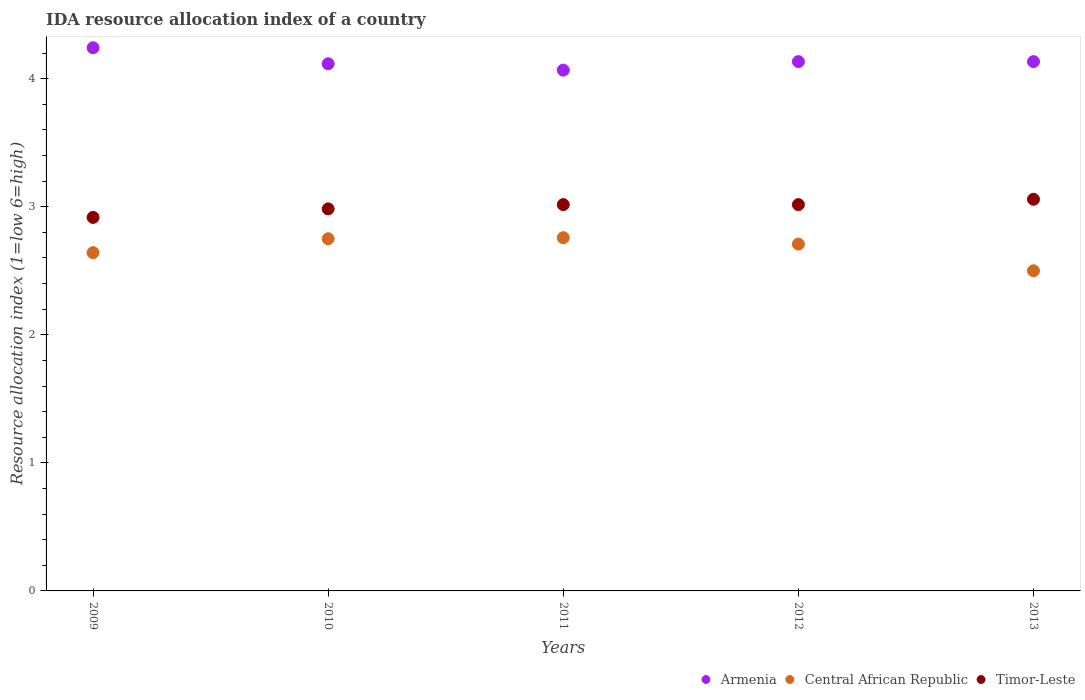How many different coloured dotlines are there?
Make the answer very short. 3. What is the IDA resource allocation index in Armenia in 2009?
Ensure brevity in your answer.  4.24. Across all years, what is the maximum IDA resource allocation index in Armenia?
Offer a very short reply. 4.24. What is the total IDA resource allocation index in Central African Republic in the graph?
Your response must be concise. 13.36. What is the difference between the IDA resource allocation index in Central African Republic in 2011 and that in 2012?
Give a very brief answer. 0.05. What is the difference between the IDA resource allocation index in Central African Republic in 2011 and the IDA resource allocation index in Armenia in 2012?
Your answer should be very brief. -1.38. What is the average IDA resource allocation index in Central African Republic per year?
Your response must be concise. 2.67. In the year 2011, what is the difference between the IDA resource allocation index in Timor-Leste and IDA resource allocation index in Central African Republic?
Offer a terse response. 0.26. In how many years, is the IDA resource allocation index in Armenia greater than 0.2?
Ensure brevity in your answer.  5. What is the ratio of the IDA resource allocation index in Timor-Leste in 2010 to that in 2013?
Provide a succinct answer. 0.98. Is the difference between the IDA resource allocation index in Timor-Leste in 2009 and 2011 greater than the difference between the IDA resource allocation index in Central African Republic in 2009 and 2011?
Offer a very short reply. Yes. What is the difference between the highest and the second highest IDA resource allocation index in Timor-Leste?
Provide a short and direct response. 0.04. What is the difference between the highest and the lowest IDA resource allocation index in Timor-Leste?
Your answer should be compact. 0.14. In how many years, is the IDA resource allocation index in Armenia greater than the average IDA resource allocation index in Armenia taken over all years?
Offer a terse response. 1. Does the IDA resource allocation index in Armenia monotonically increase over the years?
Provide a succinct answer. No. How many dotlines are there?
Give a very brief answer. 3. Does the graph contain any zero values?
Your response must be concise. No. How many legend labels are there?
Provide a succinct answer. 3. What is the title of the graph?
Your answer should be compact. IDA resource allocation index of a country. What is the label or title of the Y-axis?
Your response must be concise. Resource allocation index (1=low 6=high). What is the Resource allocation index (1=low 6=high) of Armenia in 2009?
Offer a terse response. 4.24. What is the Resource allocation index (1=low 6=high) in Central African Republic in 2009?
Provide a short and direct response. 2.64. What is the Resource allocation index (1=low 6=high) in Timor-Leste in 2009?
Your answer should be very brief. 2.92. What is the Resource allocation index (1=low 6=high) in Armenia in 2010?
Ensure brevity in your answer.  4.12. What is the Resource allocation index (1=low 6=high) of Central African Republic in 2010?
Ensure brevity in your answer.  2.75. What is the Resource allocation index (1=low 6=high) in Timor-Leste in 2010?
Make the answer very short. 2.98. What is the Resource allocation index (1=low 6=high) of Armenia in 2011?
Your response must be concise. 4.07. What is the Resource allocation index (1=low 6=high) in Central African Republic in 2011?
Make the answer very short. 2.76. What is the Resource allocation index (1=low 6=high) of Timor-Leste in 2011?
Your answer should be compact. 3.02. What is the Resource allocation index (1=low 6=high) in Armenia in 2012?
Keep it short and to the point. 4.13. What is the Resource allocation index (1=low 6=high) in Central African Republic in 2012?
Provide a short and direct response. 2.71. What is the Resource allocation index (1=low 6=high) of Timor-Leste in 2012?
Offer a terse response. 3.02. What is the Resource allocation index (1=low 6=high) of Armenia in 2013?
Your answer should be very brief. 4.13. What is the Resource allocation index (1=low 6=high) of Timor-Leste in 2013?
Your answer should be very brief. 3.06. Across all years, what is the maximum Resource allocation index (1=low 6=high) of Armenia?
Offer a terse response. 4.24. Across all years, what is the maximum Resource allocation index (1=low 6=high) in Central African Republic?
Give a very brief answer. 2.76. Across all years, what is the maximum Resource allocation index (1=low 6=high) in Timor-Leste?
Your answer should be compact. 3.06. Across all years, what is the minimum Resource allocation index (1=low 6=high) of Armenia?
Offer a very short reply. 4.07. Across all years, what is the minimum Resource allocation index (1=low 6=high) of Timor-Leste?
Your answer should be very brief. 2.92. What is the total Resource allocation index (1=low 6=high) of Armenia in the graph?
Offer a very short reply. 20.69. What is the total Resource allocation index (1=low 6=high) in Central African Republic in the graph?
Provide a short and direct response. 13.36. What is the total Resource allocation index (1=low 6=high) in Timor-Leste in the graph?
Your answer should be very brief. 14.99. What is the difference between the Resource allocation index (1=low 6=high) of Armenia in 2009 and that in 2010?
Provide a short and direct response. 0.12. What is the difference between the Resource allocation index (1=low 6=high) of Central African Republic in 2009 and that in 2010?
Provide a succinct answer. -0.11. What is the difference between the Resource allocation index (1=low 6=high) in Timor-Leste in 2009 and that in 2010?
Provide a short and direct response. -0.07. What is the difference between the Resource allocation index (1=low 6=high) of Armenia in 2009 and that in 2011?
Give a very brief answer. 0.17. What is the difference between the Resource allocation index (1=low 6=high) of Central African Republic in 2009 and that in 2011?
Your response must be concise. -0.12. What is the difference between the Resource allocation index (1=low 6=high) of Armenia in 2009 and that in 2012?
Give a very brief answer. 0.11. What is the difference between the Resource allocation index (1=low 6=high) of Central African Republic in 2009 and that in 2012?
Your answer should be very brief. -0.07. What is the difference between the Resource allocation index (1=low 6=high) in Armenia in 2009 and that in 2013?
Your answer should be compact. 0.11. What is the difference between the Resource allocation index (1=low 6=high) in Central African Republic in 2009 and that in 2013?
Keep it short and to the point. 0.14. What is the difference between the Resource allocation index (1=low 6=high) of Timor-Leste in 2009 and that in 2013?
Your response must be concise. -0.14. What is the difference between the Resource allocation index (1=low 6=high) of Armenia in 2010 and that in 2011?
Your answer should be compact. 0.05. What is the difference between the Resource allocation index (1=low 6=high) of Central African Republic in 2010 and that in 2011?
Give a very brief answer. -0.01. What is the difference between the Resource allocation index (1=low 6=high) of Timor-Leste in 2010 and that in 2011?
Offer a terse response. -0.03. What is the difference between the Resource allocation index (1=low 6=high) of Armenia in 2010 and that in 2012?
Offer a terse response. -0.02. What is the difference between the Resource allocation index (1=low 6=high) in Central African Republic in 2010 and that in 2012?
Make the answer very short. 0.04. What is the difference between the Resource allocation index (1=low 6=high) of Timor-Leste in 2010 and that in 2012?
Make the answer very short. -0.03. What is the difference between the Resource allocation index (1=low 6=high) of Armenia in 2010 and that in 2013?
Your response must be concise. -0.02. What is the difference between the Resource allocation index (1=low 6=high) in Central African Republic in 2010 and that in 2013?
Offer a very short reply. 0.25. What is the difference between the Resource allocation index (1=low 6=high) in Timor-Leste in 2010 and that in 2013?
Offer a terse response. -0.07. What is the difference between the Resource allocation index (1=low 6=high) of Armenia in 2011 and that in 2012?
Provide a short and direct response. -0.07. What is the difference between the Resource allocation index (1=low 6=high) of Armenia in 2011 and that in 2013?
Make the answer very short. -0.07. What is the difference between the Resource allocation index (1=low 6=high) of Central African Republic in 2011 and that in 2013?
Provide a short and direct response. 0.26. What is the difference between the Resource allocation index (1=low 6=high) of Timor-Leste in 2011 and that in 2013?
Provide a succinct answer. -0.04. What is the difference between the Resource allocation index (1=low 6=high) in Central African Republic in 2012 and that in 2013?
Provide a short and direct response. 0.21. What is the difference between the Resource allocation index (1=low 6=high) in Timor-Leste in 2012 and that in 2013?
Provide a short and direct response. -0.04. What is the difference between the Resource allocation index (1=low 6=high) in Armenia in 2009 and the Resource allocation index (1=low 6=high) in Central African Republic in 2010?
Give a very brief answer. 1.49. What is the difference between the Resource allocation index (1=low 6=high) in Armenia in 2009 and the Resource allocation index (1=low 6=high) in Timor-Leste in 2010?
Your response must be concise. 1.26. What is the difference between the Resource allocation index (1=low 6=high) of Central African Republic in 2009 and the Resource allocation index (1=low 6=high) of Timor-Leste in 2010?
Offer a terse response. -0.34. What is the difference between the Resource allocation index (1=low 6=high) in Armenia in 2009 and the Resource allocation index (1=low 6=high) in Central African Republic in 2011?
Provide a succinct answer. 1.48. What is the difference between the Resource allocation index (1=low 6=high) of Armenia in 2009 and the Resource allocation index (1=low 6=high) of Timor-Leste in 2011?
Offer a terse response. 1.23. What is the difference between the Resource allocation index (1=low 6=high) of Central African Republic in 2009 and the Resource allocation index (1=low 6=high) of Timor-Leste in 2011?
Keep it short and to the point. -0.38. What is the difference between the Resource allocation index (1=low 6=high) of Armenia in 2009 and the Resource allocation index (1=low 6=high) of Central African Republic in 2012?
Give a very brief answer. 1.53. What is the difference between the Resource allocation index (1=low 6=high) in Armenia in 2009 and the Resource allocation index (1=low 6=high) in Timor-Leste in 2012?
Your answer should be very brief. 1.23. What is the difference between the Resource allocation index (1=low 6=high) of Central African Republic in 2009 and the Resource allocation index (1=low 6=high) of Timor-Leste in 2012?
Offer a very short reply. -0.38. What is the difference between the Resource allocation index (1=low 6=high) of Armenia in 2009 and the Resource allocation index (1=low 6=high) of Central African Republic in 2013?
Ensure brevity in your answer.  1.74. What is the difference between the Resource allocation index (1=low 6=high) of Armenia in 2009 and the Resource allocation index (1=low 6=high) of Timor-Leste in 2013?
Ensure brevity in your answer.  1.18. What is the difference between the Resource allocation index (1=low 6=high) of Central African Republic in 2009 and the Resource allocation index (1=low 6=high) of Timor-Leste in 2013?
Provide a succinct answer. -0.42. What is the difference between the Resource allocation index (1=low 6=high) in Armenia in 2010 and the Resource allocation index (1=low 6=high) in Central African Republic in 2011?
Provide a short and direct response. 1.36. What is the difference between the Resource allocation index (1=low 6=high) of Armenia in 2010 and the Resource allocation index (1=low 6=high) of Timor-Leste in 2011?
Offer a very short reply. 1.1. What is the difference between the Resource allocation index (1=low 6=high) of Central African Republic in 2010 and the Resource allocation index (1=low 6=high) of Timor-Leste in 2011?
Your response must be concise. -0.27. What is the difference between the Resource allocation index (1=low 6=high) of Armenia in 2010 and the Resource allocation index (1=low 6=high) of Central African Republic in 2012?
Make the answer very short. 1.41. What is the difference between the Resource allocation index (1=low 6=high) of Central African Republic in 2010 and the Resource allocation index (1=low 6=high) of Timor-Leste in 2012?
Give a very brief answer. -0.27. What is the difference between the Resource allocation index (1=low 6=high) of Armenia in 2010 and the Resource allocation index (1=low 6=high) of Central African Republic in 2013?
Keep it short and to the point. 1.62. What is the difference between the Resource allocation index (1=low 6=high) of Armenia in 2010 and the Resource allocation index (1=low 6=high) of Timor-Leste in 2013?
Offer a very short reply. 1.06. What is the difference between the Resource allocation index (1=low 6=high) in Central African Republic in 2010 and the Resource allocation index (1=low 6=high) in Timor-Leste in 2013?
Provide a short and direct response. -0.31. What is the difference between the Resource allocation index (1=low 6=high) of Armenia in 2011 and the Resource allocation index (1=low 6=high) of Central African Republic in 2012?
Your answer should be compact. 1.36. What is the difference between the Resource allocation index (1=low 6=high) in Central African Republic in 2011 and the Resource allocation index (1=low 6=high) in Timor-Leste in 2012?
Your response must be concise. -0.26. What is the difference between the Resource allocation index (1=low 6=high) in Armenia in 2011 and the Resource allocation index (1=low 6=high) in Central African Republic in 2013?
Offer a very short reply. 1.57. What is the difference between the Resource allocation index (1=low 6=high) in Armenia in 2011 and the Resource allocation index (1=low 6=high) in Timor-Leste in 2013?
Your answer should be compact. 1.01. What is the difference between the Resource allocation index (1=low 6=high) of Armenia in 2012 and the Resource allocation index (1=low 6=high) of Central African Republic in 2013?
Keep it short and to the point. 1.63. What is the difference between the Resource allocation index (1=low 6=high) of Armenia in 2012 and the Resource allocation index (1=low 6=high) of Timor-Leste in 2013?
Give a very brief answer. 1.07. What is the difference between the Resource allocation index (1=low 6=high) in Central African Republic in 2012 and the Resource allocation index (1=low 6=high) in Timor-Leste in 2013?
Provide a short and direct response. -0.35. What is the average Resource allocation index (1=low 6=high) in Armenia per year?
Offer a terse response. 4.14. What is the average Resource allocation index (1=low 6=high) in Central African Republic per year?
Your response must be concise. 2.67. What is the average Resource allocation index (1=low 6=high) in Timor-Leste per year?
Make the answer very short. 3. In the year 2009, what is the difference between the Resource allocation index (1=low 6=high) of Armenia and Resource allocation index (1=low 6=high) of Central African Republic?
Ensure brevity in your answer.  1.6. In the year 2009, what is the difference between the Resource allocation index (1=low 6=high) in Armenia and Resource allocation index (1=low 6=high) in Timor-Leste?
Provide a succinct answer. 1.32. In the year 2009, what is the difference between the Resource allocation index (1=low 6=high) of Central African Republic and Resource allocation index (1=low 6=high) of Timor-Leste?
Your response must be concise. -0.28. In the year 2010, what is the difference between the Resource allocation index (1=low 6=high) of Armenia and Resource allocation index (1=low 6=high) of Central African Republic?
Make the answer very short. 1.37. In the year 2010, what is the difference between the Resource allocation index (1=low 6=high) in Armenia and Resource allocation index (1=low 6=high) in Timor-Leste?
Offer a very short reply. 1.13. In the year 2010, what is the difference between the Resource allocation index (1=low 6=high) of Central African Republic and Resource allocation index (1=low 6=high) of Timor-Leste?
Give a very brief answer. -0.23. In the year 2011, what is the difference between the Resource allocation index (1=low 6=high) of Armenia and Resource allocation index (1=low 6=high) of Central African Republic?
Offer a terse response. 1.31. In the year 2011, what is the difference between the Resource allocation index (1=low 6=high) in Armenia and Resource allocation index (1=low 6=high) in Timor-Leste?
Offer a terse response. 1.05. In the year 2011, what is the difference between the Resource allocation index (1=low 6=high) in Central African Republic and Resource allocation index (1=low 6=high) in Timor-Leste?
Ensure brevity in your answer.  -0.26. In the year 2012, what is the difference between the Resource allocation index (1=low 6=high) of Armenia and Resource allocation index (1=low 6=high) of Central African Republic?
Make the answer very short. 1.43. In the year 2012, what is the difference between the Resource allocation index (1=low 6=high) in Armenia and Resource allocation index (1=low 6=high) in Timor-Leste?
Your answer should be compact. 1.12. In the year 2012, what is the difference between the Resource allocation index (1=low 6=high) of Central African Republic and Resource allocation index (1=low 6=high) of Timor-Leste?
Give a very brief answer. -0.31. In the year 2013, what is the difference between the Resource allocation index (1=low 6=high) of Armenia and Resource allocation index (1=low 6=high) of Central African Republic?
Make the answer very short. 1.63. In the year 2013, what is the difference between the Resource allocation index (1=low 6=high) in Armenia and Resource allocation index (1=low 6=high) in Timor-Leste?
Provide a succinct answer. 1.07. In the year 2013, what is the difference between the Resource allocation index (1=low 6=high) of Central African Republic and Resource allocation index (1=low 6=high) of Timor-Leste?
Give a very brief answer. -0.56. What is the ratio of the Resource allocation index (1=low 6=high) in Armenia in 2009 to that in 2010?
Ensure brevity in your answer.  1.03. What is the ratio of the Resource allocation index (1=low 6=high) of Central African Republic in 2009 to that in 2010?
Offer a very short reply. 0.96. What is the ratio of the Resource allocation index (1=low 6=high) in Timor-Leste in 2009 to that in 2010?
Provide a succinct answer. 0.98. What is the ratio of the Resource allocation index (1=low 6=high) in Armenia in 2009 to that in 2011?
Offer a terse response. 1.04. What is the ratio of the Resource allocation index (1=low 6=high) in Central African Republic in 2009 to that in 2011?
Make the answer very short. 0.96. What is the ratio of the Resource allocation index (1=low 6=high) of Timor-Leste in 2009 to that in 2011?
Your answer should be compact. 0.97. What is the ratio of the Resource allocation index (1=low 6=high) in Armenia in 2009 to that in 2012?
Keep it short and to the point. 1.03. What is the ratio of the Resource allocation index (1=low 6=high) in Central African Republic in 2009 to that in 2012?
Offer a very short reply. 0.98. What is the ratio of the Resource allocation index (1=low 6=high) of Timor-Leste in 2009 to that in 2012?
Offer a terse response. 0.97. What is the ratio of the Resource allocation index (1=low 6=high) of Armenia in 2009 to that in 2013?
Provide a short and direct response. 1.03. What is the ratio of the Resource allocation index (1=low 6=high) in Central African Republic in 2009 to that in 2013?
Keep it short and to the point. 1.06. What is the ratio of the Resource allocation index (1=low 6=high) of Timor-Leste in 2009 to that in 2013?
Make the answer very short. 0.95. What is the ratio of the Resource allocation index (1=low 6=high) of Armenia in 2010 to that in 2011?
Your answer should be compact. 1.01. What is the ratio of the Resource allocation index (1=low 6=high) of Armenia in 2010 to that in 2012?
Offer a very short reply. 1. What is the ratio of the Resource allocation index (1=low 6=high) of Central African Republic in 2010 to that in 2012?
Offer a very short reply. 1.02. What is the ratio of the Resource allocation index (1=low 6=high) in Central African Republic in 2010 to that in 2013?
Offer a very short reply. 1.1. What is the ratio of the Resource allocation index (1=low 6=high) in Timor-Leste in 2010 to that in 2013?
Provide a succinct answer. 0.98. What is the ratio of the Resource allocation index (1=low 6=high) in Armenia in 2011 to that in 2012?
Make the answer very short. 0.98. What is the ratio of the Resource allocation index (1=low 6=high) in Central African Republic in 2011 to that in 2012?
Your response must be concise. 1.02. What is the ratio of the Resource allocation index (1=low 6=high) in Armenia in 2011 to that in 2013?
Your answer should be compact. 0.98. What is the ratio of the Resource allocation index (1=low 6=high) in Central African Republic in 2011 to that in 2013?
Offer a very short reply. 1.1. What is the ratio of the Resource allocation index (1=low 6=high) of Timor-Leste in 2011 to that in 2013?
Provide a succinct answer. 0.99. What is the ratio of the Resource allocation index (1=low 6=high) of Armenia in 2012 to that in 2013?
Your response must be concise. 1. What is the ratio of the Resource allocation index (1=low 6=high) in Central African Republic in 2012 to that in 2013?
Make the answer very short. 1.08. What is the ratio of the Resource allocation index (1=low 6=high) in Timor-Leste in 2012 to that in 2013?
Your response must be concise. 0.99. What is the difference between the highest and the second highest Resource allocation index (1=low 6=high) of Armenia?
Give a very brief answer. 0.11. What is the difference between the highest and the second highest Resource allocation index (1=low 6=high) in Central African Republic?
Make the answer very short. 0.01. What is the difference between the highest and the second highest Resource allocation index (1=low 6=high) in Timor-Leste?
Make the answer very short. 0.04. What is the difference between the highest and the lowest Resource allocation index (1=low 6=high) of Armenia?
Ensure brevity in your answer.  0.17. What is the difference between the highest and the lowest Resource allocation index (1=low 6=high) of Central African Republic?
Provide a short and direct response. 0.26. What is the difference between the highest and the lowest Resource allocation index (1=low 6=high) of Timor-Leste?
Offer a very short reply. 0.14. 